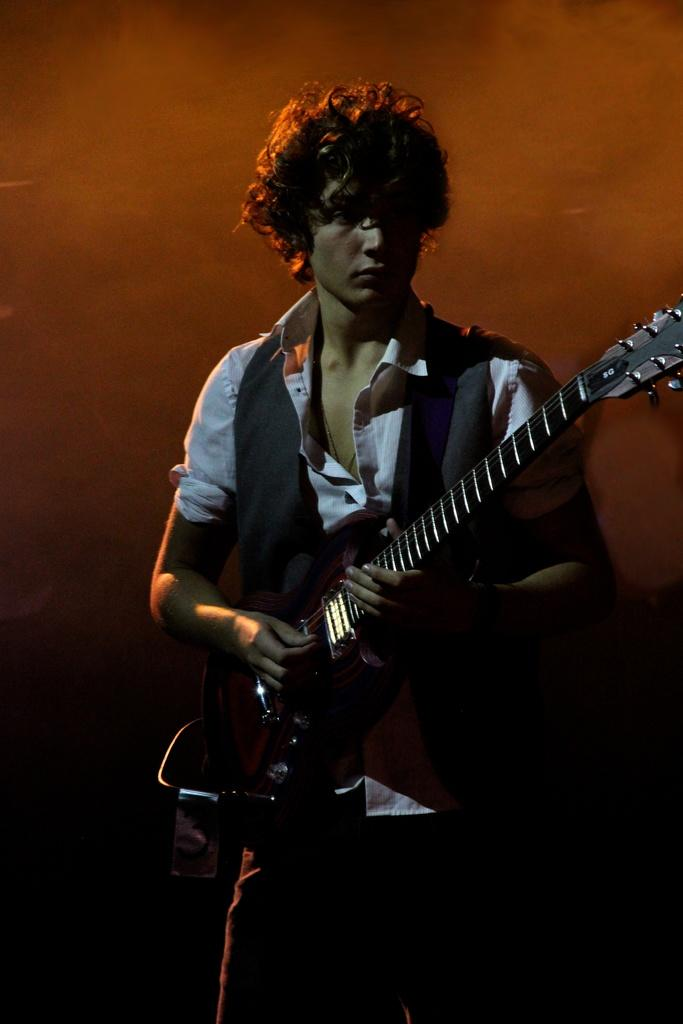Who is the person in the image? There is a man in the image. What is the man doing in the image? The man is standing and playing the guitar. What is the man holding in the image? The man is holding a guitar. How is the man playing the guitar in the image? The man is playing the guitar with his hand. What type of clam can be seen crawling on the guitar in the image? There are no clams present in the image; the man is playing the guitar with his hand. 